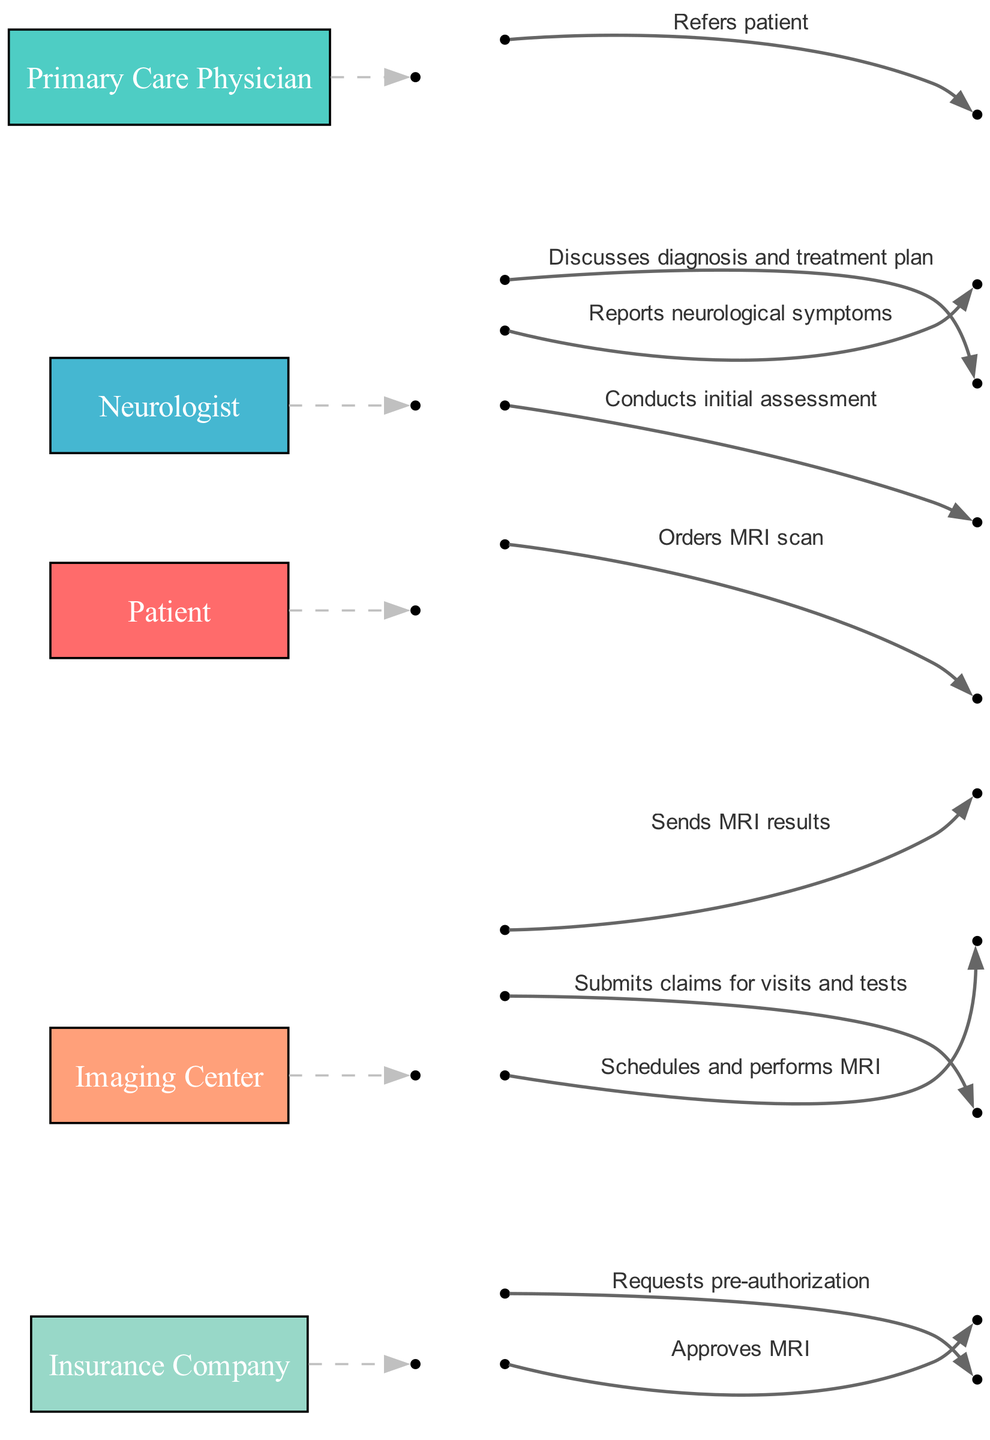What is the first action performed in the diagram? The first action in the diagram is when the Patient reports neurological symptoms to the Primary Care Physician. This is the starting point of the patient journey depicted in the sequence diagram.
Answer: Reports neurological symptoms How many actors are involved in the sequence diagram? The sequence diagram features five distinct actors: Patient, Primary Care Physician, Neurologist, Imaging Center, and Insurance Company. This counts all the unique participants in the patient's journey.
Answer: 5 Who conducts the initial assessment? The Neurologist is responsible for conducting the initial assessment. This action follows the referral from the Primary Care Physician to the Neurologist.
Answer: Neurologist What type of scan is ordered by the Neurologist? The Neurologist orders an MRI scan. This is explicitly stated in the sequence and indicates a diagnostic step in the patient's evaluation process.
Answer: MRI scan What must the Imaging Center obtain before performing the MRI? The Imaging Center must obtain pre-authorization from the Insurance Company before they can perform the MRI. This step is crucial to ensure that the procedure is covered by insurance.
Answer: Pre-authorization How many sequential steps are there between the Patient and the Insurance Company? There are two distinct steps involving the Insurance Company: the Insurance Company approves the MRI scan after a request from the Imaging Center, and the Patient submits claims for visits and tests to the Insurance Company. This represents the interactions between these two entities.
Answer: 2 Which actor sends the MRI results? The Imaging Center sends the MRI results to the Neurologist. This step is part of the process that allows the Neurologist to discuss the diagnosis with the Patient.
Answer: Imaging Center What message does the Neurologist convey to the Patient after receiving the MRI results? The Neurologist discusses the diagnosis and treatment plan with the Patient after receiving the MRI results. This message indicates a crucial part of the patient care pathway.
Answer: Discusses diagnosis and treatment plan What action is taken by the Patient after receiving medical care? The Patient submits claims for visits and tests to the Insurance Company, initiating the reimbursement process following the medical interventions received.
Answer: Submits claims for visits and tests 